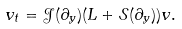<formula> <loc_0><loc_0><loc_500><loc_500>v _ { t } = \mathcal { J } ( \partial _ { y } ) ( L + \mathcal { S } ( \partial _ { y } ) ) v .</formula> 